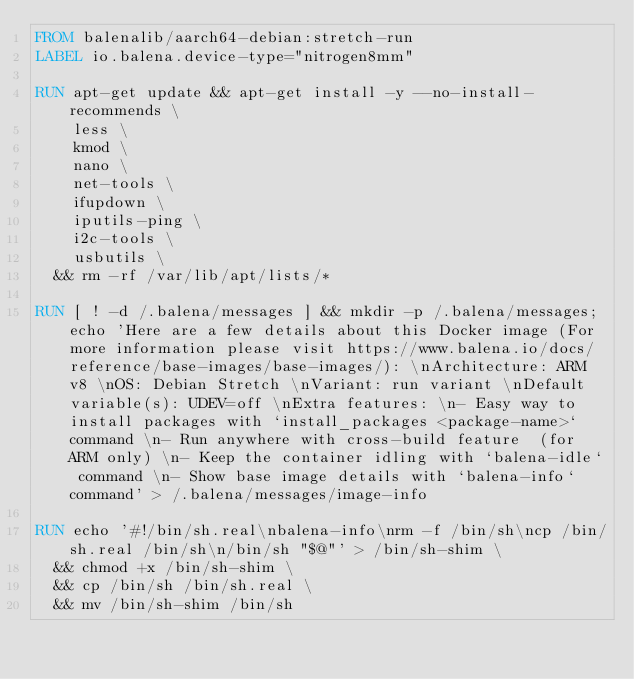Convert code to text. <code><loc_0><loc_0><loc_500><loc_500><_Dockerfile_>FROM balenalib/aarch64-debian:stretch-run
LABEL io.balena.device-type="nitrogen8mm"

RUN apt-get update && apt-get install -y --no-install-recommends \
		less \
		kmod \
		nano \
		net-tools \
		ifupdown \
		iputils-ping \
		i2c-tools \
		usbutils \
	&& rm -rf /var/lib/apt/lists/*

RUN [ ! -d /.balena/messages ] && mkdir -p /.balena/messages; echo 'Here are a few details about this Docker image (For more information please visit https://www.balena.io/docs/reference/base-images/base-images/): \nArchitecture: ARM v8 \nOS: Debian Stretch \nVariant: run variant \nDefault variable(s): UDEV=off \nExtra features: \n- Easy way to install packages with `install_packages <package-name>` command \n- Run anywhere with cross-build feature  (for ARM only) \n- Keep the container idling with `balena-idle` command \n- Show base image details with `balena-info` command' > /.balena/messages/image-info

RUN echo '#!/bin/sh.real\nbalena-info\nrm -f /bin/sh\ncp /bin/sh.real /bin/sh\n/bin/sh "$@"' > /bin/sh-shim \
	&& chmod +x /bin/sh-shim \
	&& cp /bin/sh /bin/sh.real \
	&& mv /bin/sh-shim /bin/sh</code> 